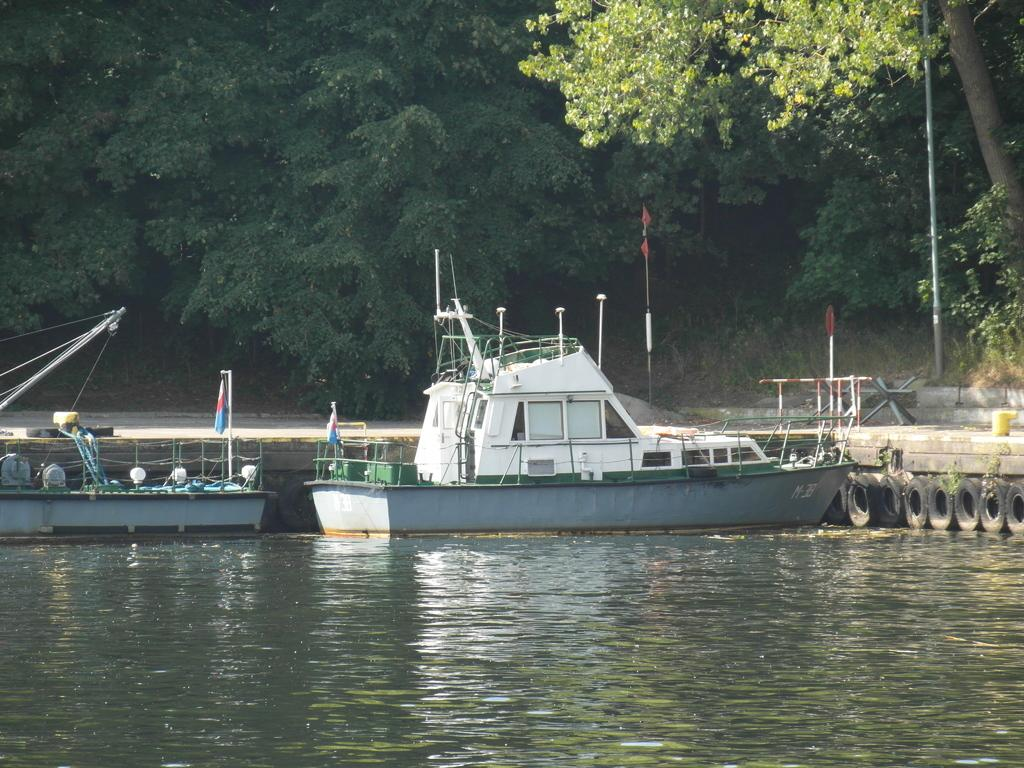What is the primary element visible in the image? There is water in the image. What can be seen floating on the water? There are two boats in the image. What is located beside the boats? There is a path beside the boats. What type of vegetation is present along the path? Trees are present along the path. What structure can be seen near the trees? There is a pole near the trees. What type of dress is being folded on the pole in the image? There is no dress present in the image, nor is there any folding activity taking place. 